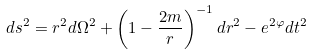Convert formula to latex. <formula><loc_0><loc_0><loc_500><loc_500>d s ^ { 2 } = r ^ { 2 } d \Omega ^ { 2 } + \left ( 1 - \frac { 2 m } r \right ) ^ { - 1 } d r ^ { 2 } - e ^ { 2 \varphi } d t ^ { 2 }</formula> 